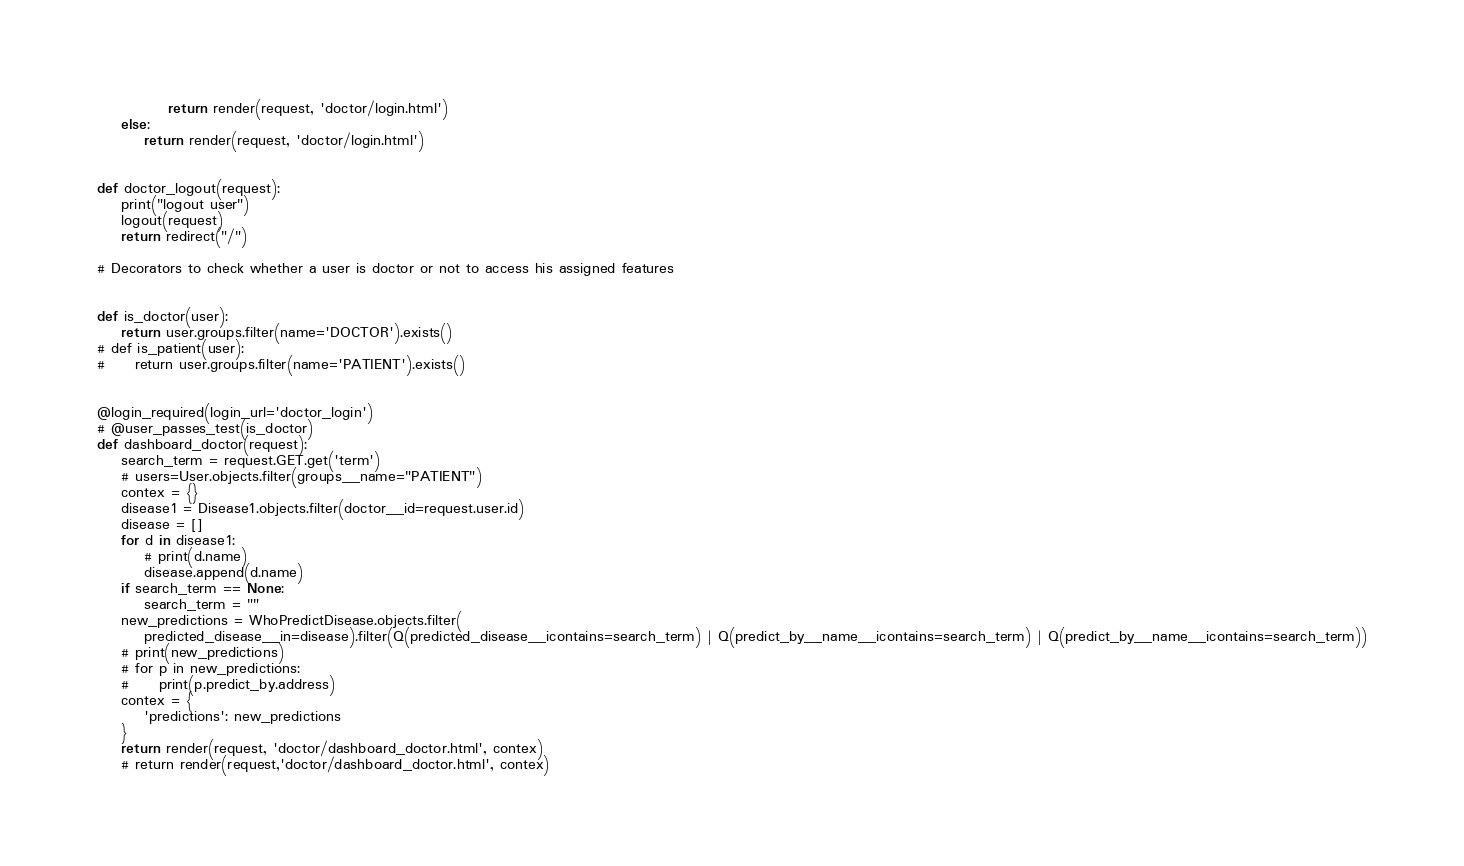Convert code to text. <code><loc_0><loc_0><loc_500><loc_500><_Python_>
            return render(request, 'doctor/login.html')
    else:
        return render(request, 'doctor/login.html')


def doctor_logout(request):
    print("logout user")
    logout(request)
    return redirect("/")

# Decorators to check whether a user is doctor or not to access his assigned features


def is_doctor(user):
    return user.groups.filter(name='DOCTOR').exists()
# def is_patient(user):
#     return user.groups.filter(name='PATIENT').exists()


@login_required(login_url='doctor_login')
# @user_passes_test(is_doctor)
def dashboard_doctor(request):
    search_term = request.GET.get('term')
    # users=User.objects.filter(groups__name="PATIENT")
    contex = {}
    disease1 = Disease1.objects.filter(doctor__id=request.user.id)
    disease = []
    for d in disease1:
        # print(d.name)
        disease.append(d.name)
    if search_term == None:
        search_term = ""
    new_predictions = WhoPredictDisease.objects.filter(
        predicted_disease__in=disease).filter(Q(predicted_disease__icontains=search_term) | Q(predict_by__name__icontains=search_term) | Q(predict_by__name__icontains=search_term))
    # print(new_predictions)
    # for p in new_predictions:
    #     print(p.predict_by.address)
    contex = {
        'predictions': new_predictions
    }
    return render(request, 'doctor/dashboard_doctor.html', contex)
    # return render(request,'doctor/dashboard_doctor.html', contex)
</code> 